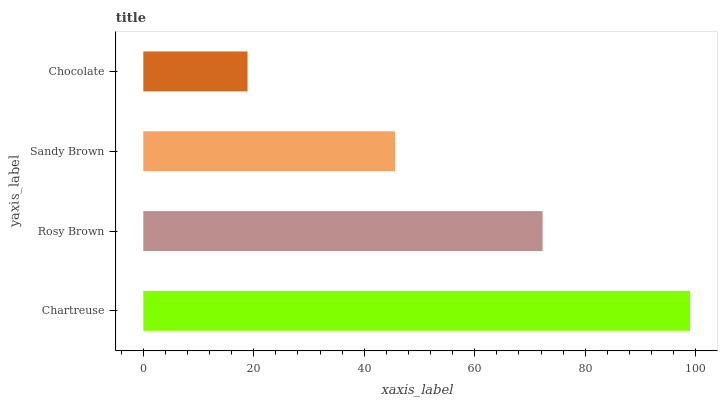Is Chocolate the minimum?
Answer yes or no. Yes. Is Chartreuse the maximum?
Answer yes or no. Yes. Is Rosy Brown the minimum?
Answer yes or no. No. Is Rosy Brown the maximum?
Answer yes or no. No. Is Chartreuse greater than Rosy Brown?
Answer yes or no. Yes. Is Rosy Brown less than Chartreuse?
Answer yes or no. Yes. Is Rosy Brown greater than Chartreuse?
Answer yes or no. No. Is Chartreuse less than Rosy Brown?
Answer yes or no. No. Is Rosy Brown the high median?
Answer yes or no. Yes. Is Sandy Brown the low median?
Answer yes or no. Yes. Is Chocolate the high median?
Answer yes or no. No. Is Chartreuse the low median?
Answer yes or no. No. 